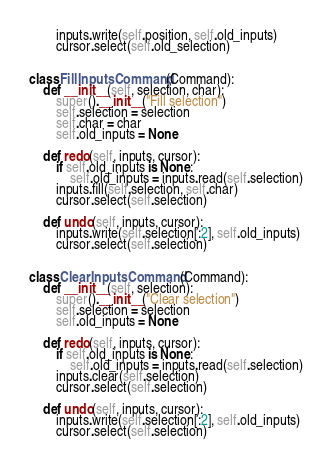Convert code to text. <code><loc_0><loc_0><loc_500><loc_500><_Python_>        inputs.write(self.position, self.old_inputs)
        cursor.select(self.old_selection)


class FillInputsCommand(Command):
    def __init__(self, selection, char):
        super().__init__("Fill selection")
        self.selection = selection
        self.char = char
        self.old_inputs = None

    def redo(self, inputs, cursor):
        if self.old_inputs is None:
            self.old_inputs = inputs.read(self.selection)
        inputs.fill(self.selection, self.char)
        cursor.select(self.selection)

    def undo(self, inputs, cursor):
        inputs.write(self.selection[:2], self.old_inputs)
        cursor.select(self.selection)


class ClearInputsCommand(Command):
    def __init__(self, selection):
        super().__init__("Clear selection")
        self.selection = selection
        self.old_inputs = None

    def redo(self, inputs, cursor):
        if self.old_inputs is None:
            self.old_inputs = inputs.read(self.selection)
        inputs.clear(self.selection)
        cursor.select(self.selection)

    def undo(self, inputs, cursor):
        inputs.write(self.selection[:2], self.old_inputs)
        cursor.select(self.selection)

</code> 